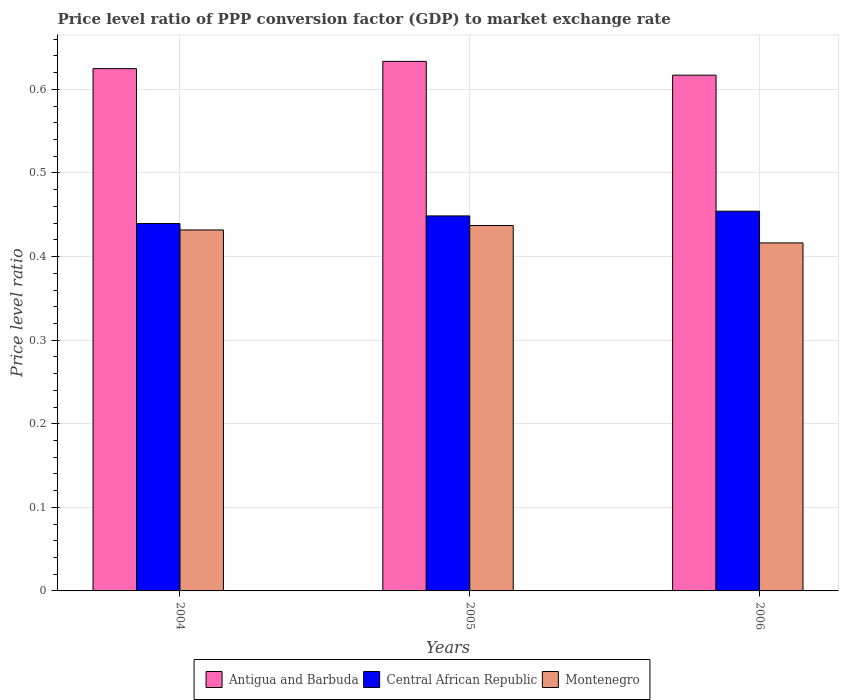Are the number of bars per tick equal to the number of legend labels?
Your answer should be very brief. Yes. What is the label of the 2nd group of bars from the left?
Your answer should be very brief. 2005. What is the price level ratio in Antigua and Barbuda in 2005?
Provide a succinct answer. 0.63. Across all years, what is the maximum price level ratio in Central African Republic?
Offer a terse response. 0.45. Across all years, what is the minimum price level ratio in Central African Republic?
Your answer should be very brief. 0.44. In which year was the price level ratio in Central African Republic minimum?
Your answer should be very brief. 2004. What is the total price level ratio in Central African Republic in the graph?
Your response must be concise. 1.34. What is the difference between the price level ratio in Montenegro in 2005 and that in 2006?
Your answer should be compact. 0.02. What is the difference between the price level ratio in Central African Republic in 2005 and the price level ratio in Montenegro in 2004?
Ensure brevity in your answer.  0.02. What is the average price level ratio in Antigua and Barbuda per year?
Give a very brief answer. 0.63. In the year 2004, what is the difference between the price level ratio in Central African Republic and price level ratio in Antigua and Barbuda?
Provide a short and direct response. -0.19. What is the ratio of the price level ratio in Central African Republic in 2005 to that in 2006?
Your answer should be compact. 0.99. Is the difference between the price level ratio in Central African Republic in 2004 and 2005 greater than the difference between the price level ratio in Antigua and Barbuda in 2004 and 2005?
Keep it short and to the point. No. What is the difference between the highest and the second highest price level ratio in Antigua and Barbuda?
Make the answer very short. 0.01. What is the difference between the highest and the lowest price level ratio in Antigua and Barbuda?
Provide a short and direct response. 0.02. Is the sum of the price level ratio in Central African Republic in 2005 and 2006 greater than the maximum price level ratio in Montenegro across all years?
Make the answer very short. Yes. What does the 1st bar from the left in 2006 represents?
Ensure brevity in your answer.  Antigua and Barbuda. What does the 2nd bar from the right in 2004 represents?
Keep it short and to the point. Central African Republic. Are all the bars in the graph horizontal?
Give a very brief answer. No. How many years are there in the graph?
Ensure brevity in your answer.  3. Are the values on the major ticks of Y-axis written in scientific E-notation?
Provide a short and direct response. No. Where does the legend appear in the graph?
Offer a very short reply. Bottom center. How are the legend labels stacked?
Make the answer very short. Horizontal. What is the title of the graph?
Give a very brief answer. Price level ratio of PPP conversion factor (GDP) to market exchange rate. Does "Israel" appear as one of the legend labels in the graph?
Make the answer very short. No. What is the label or title of the X-axis?
Provide a short and direct response. Years. What is the label or title of the Y-axis?
Your answer should be very brief. Price level ratio. What is the Price level ratio of Antigua and Barbuda in 2004?
Offer a terse response. 0.62. What is the Price level ratio of Central African Republic in 2004?
Ensure brevity in your answer.  0.44. What is the Price level ratio in Montenegro in 2004?
Your response must be concise. 0.43. What is the Price level ratio of Antigua and Barbuda in 2005?
Make the answer very short. 0.63. What is the Price level ratio in Central African Republic in 2005?
Provide a short and direct response. 0.45. What is the Price level ratio in Montenegro in 2005?
Your answer should be compact. 0.44. What is the Price level ratio in Antigua and Barbuda in 2006?
Make the answer very short. 0.62. What is the Price level ratio in Central African Republic in 2006?
Your answer should be compact. 0.45. What is the Price level ratio of Montenegro in 2006?
Provide a short and direct response. 0.42. Across all years, what is the maximum Price level ratio of Antigua and Barbuda?
Provide a succinct answer. 0.63. Across all years, what is the maximum Price level ratio of Central African Republic?
Ensure brevity in your answer.  0.45. Across all years, what is the maximum Price level ratio of Montenegro?
Provide a succinct answer. 0.44. Across all years, what is the minimum Price level ratio in Antigua and Barbuda?
Your response must be concise. 0.62. Across all years, what is the minimum Price level ratio in Central African Republic?
Offer a very short reply. 0.44. Across all years, what is the minimum Price level ratio of Montenegro?
Offer a terse response. 0.42. What is the total Price level ratio of Antigua and Barbuda in the graph?
Your answer should be very brief. 1.88. What is the total Price level ratio of Central African Republic in the graph?
Your answer should be very brief. 1.34. What is the total Price level ratio in Montenegro in the graph?
Offer a terse response. 1.29. What is the difference between the Price level ratio in Antigua and Barbuda in 2004 and that in 2005?
Provide a succinct answer. -0.01. What is the difference between the Price level ratio in Central African Republic in 2004 and that in 2005?
Offer a very short reply. -0.01. What is the difference between the Price level ratio in Montenegro in 2004 and that in 2005?
Make the answer very short. -0.01. What is the difference between the Price level ratio in Antigua and Barbuda in 2004 and that in 2006?
Ensure brevity in your answer.  0.01. What is the difference between the Price level ratio of Central African Republic in 2004 and that in 2006?
Offer a terse response. -0.01. What is the difference between the Price level ratio in Montenegro in 2004 and that in 2006?
Provide a short and direct response. 0.02. What is the difference between the Price level ratio of Antigua and Barbuda in 2005 and that in 2006?
Offer a very short reply. 0.02. What is the difference between the Price level ratio in Central African Republic in 2005 and that in 2006?
Provide a short and direct response. -0.01. What is the difference between the Price level ratio in Montenegro in 2005 and that in 2006?
Ensure brevity in your answer.  0.02. What is the difference between the Price level ratio of Antigua and Barbuda in 2004 and the Price level ratio of Central African Republic in 2005?
Offer a very short reply. 0.18. What is the difference between the Price level ratio of Antigua and Barbuda in 2004 and the Price level ratio of Montenegro in 2005?
Your response must be concise. 0.19. What is the difference between the Price level ratio of Central African Republic in 2004 and the Price level ratio of Montenegro in 2005?
Keep it short and to the point. 0. What is the difference between the Price level ratio in Antigua and Barbuda in 2004 and the Price level ratio in Central African Republic in 2006?
Make the answer very short. 0.17. What is the difference between the Price level ratio of Antigua and Barbuda in 2004 and the Price level ratio of Montenegro in 2006?
Offer a very short reply. 0.21. What is the difference between the Price level ratio in Central African Republic in 2004 and the Price level ratio in Montenegro in 2006?
Make the answer very short. 0.02. What is the difference between the Price level ratio of Antigua and Barbuda in 2005 and the Price level ratio of Central African Republic in 2006?
Make the answer very short. 0.18. What is the difference between the Price level ratio of Antigua and Barbuda in 2005 and the Price level ratio of Montenegro in 2006?
Your answer should be very brief. 0.22. What is the difference between the Price level ratio of Central African Republic in 2005 and the Price level ratio of Montenegro in 2006?
Your answer should be very brief. 0.03. What is the average Price level ratio in Antigua and Barbuda per year?
Provide a short and direct response. 0.63. What is the average Price level ratio of Central African Republic per year?
Offer a terse response. 0.45. What is the average Price level ratio in Montenegro per year?
Keep it short and to the point. 0.43. In the year 2004, what is the difference between the Price level ratio of Antigua and Barbuda and Price level ratio of Central African Republic?
Provide a succinct answer. 0.19. In the year 2004, what is the difference between the Price level ratio in Antigua and Barbuda and Price level ratio in Montenegro?
Your answer should be compact. 0.19. In the year 2004, what is the difference between the Price level ratio of Central African Republic and Price level ratio of Montenegro?
Offer a very short reply. 0.01. In the year 2005, what is the difference between the Price level ratio in Antigua and Barbuda and Price level ratio in Central African Republic?
Your answer should be compact. 0.18. In the year 2005, what is the difference between the Price level ratio of Antigua and Barbuda and Price level ratio of Montenegro?
Your response must be concise. 0.2. In the year 2005, what is the difference between the Price level ratio of Central African Republic and Price level ratio of Montenegro?
Offer a very short reply. 0.01. In the year 2006, what is the difference between the Price level ratio of Antigua and Barbuda and Price level ratio of Central African Republic?
Your answer should be compact. 0.16. In the year 2006, what is the difference between the Price level ratio in Antigua and Barbuda and Price level ratio in Montenegro?
Ensure brevity in your answer.  0.2. In the year 2006, what is the difference between the Price level ratio of Central African Republic and Price level ratio of Montenegro?
Provide a succinct answer. 0.04. What is the ratio of the Price level ratio of Antigua and Barbuda in 2004 to that in 2005?
Your answer should be compact. 0.99. What is the ratio of the Price level ratio of Central African Republic in 2004 to that in 2005?
Keep it short and to the point. 0.98. What is the ratio of the Price level ratio in Antigua and Barbuda in 2004 to that in 2006?
Make the answer very short. 1.01. What is the ratio of the Price level ratio of Central African Republic in 2004 to that in 2006?
Your response must be concise. 0.97. What is the ratio of the Price level ratio of Montenegro in 2004 to that in 2006?
Offer a very short reply. 1.04. What is the ratio of the Price level ratio in Antigua and Barbuda in 2005 to that in 2006?
Offer a terse response. 1.03. What is the ratio of the Price level ratio in Central African Republic in 2005 to that in 2006?
Provide a short and direct response. 0.99. What is the ratio of the Price level ratio in Montenegro in 2005 to that in 2006?
Offer a terse response. 1.05. What is the difference between the highest and the second highest Price level ratio of Antigua and Barbuda?
Make the answer very short. 0.01. What is the difference between the highest and the second highest Price level ratio of Central African Republic?
Offer a terse response. 0.01. What is the difference between the highest and the second highest Price level ratio in Montenegro?
Ensure brevity in your answer.  0.01. What is the difference between the highest and the lowest Price level ratio of Antigua and Barbuda?
Provide a short and direct response. 0.02. What is the difference between the highest and the lowest Price level ratio in Central African Republic?
Your answer should be compact. 0.01. What is the difference between the highest and the lowest Price level ratio of Montenegro?
Your answer should be very brief. 0.02. 